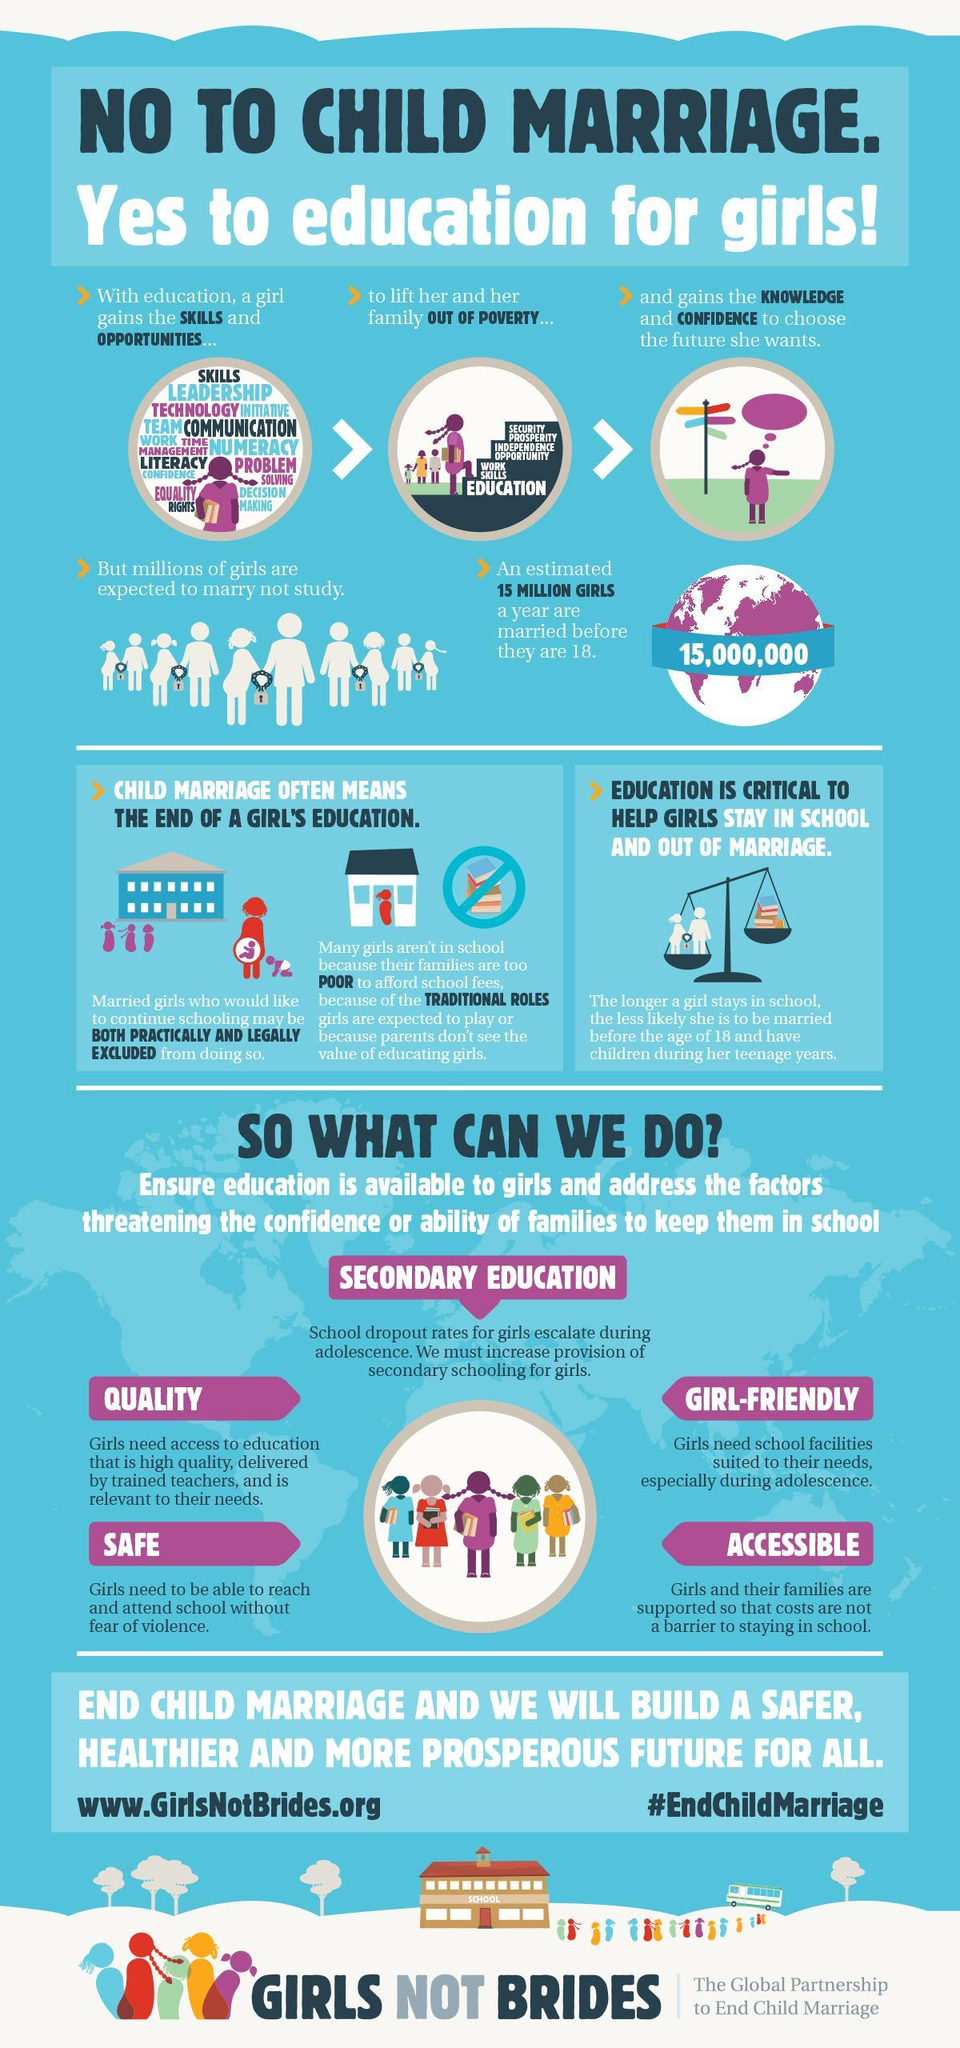What is the estimated number of minor girls in the world who get married?
Answer the question with a short phrase. 15,000,000 What is the solution for building a safer, healthier and more prosperous future for all? ending child marriage 